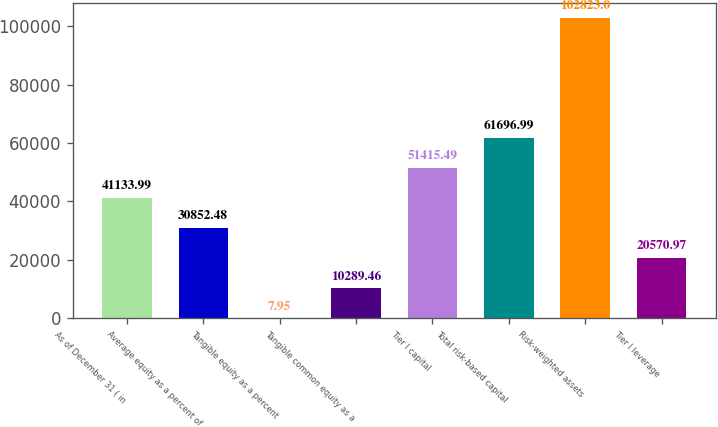<chart> <loc_0><loc_0><loc_500><loc_500><bar_chart><fcel>As of December 31 ( in<fcel>Average equity as a percent of<fcel>Tangible equity as a percent<fcel>Tangible common equity as a<fcel>Tier I capital<fcel>Total risk-based capital<fcel>Risk-weighted assets<fcel>Tier I leverage<nl><fcel>41134<fcel>30852.5<fcel>7.95<fcel>10289.5<fcel>51415.5<fcel>61697<fcel>102823<fcel>20571<nl></chart> 